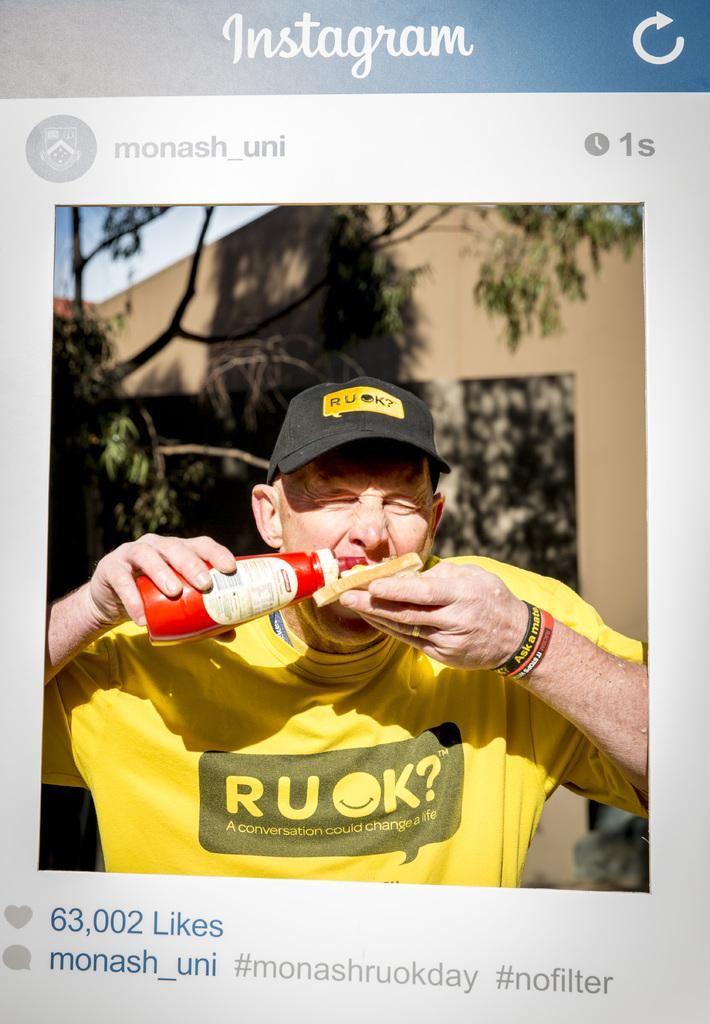<image>
Give a short and clear explanation of the subsequent image. A man eating something in a yellow tshirt that says R U OK 